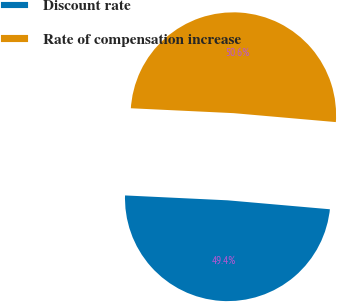Convert chart to OTSL. <chart><loc_0><loc_0><loc_500><loc_500><pie_chart><fcel>Discount rate<fcel>Rate of compensation increase<nl><fcel>49.37%<fcel>50.63%<nl></chart> 